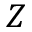<formula> <loc_0><loc_0><loc_500><loc_500>Z</formula> 